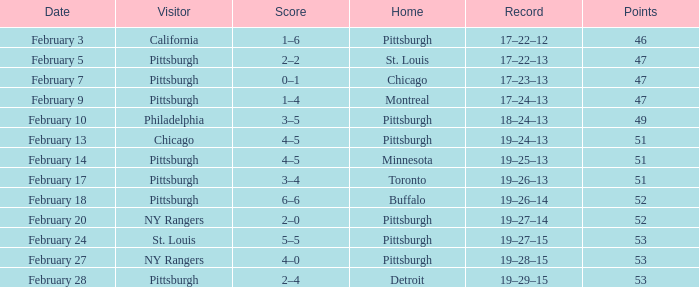Which Score has a Date of february 9? 1–4. 